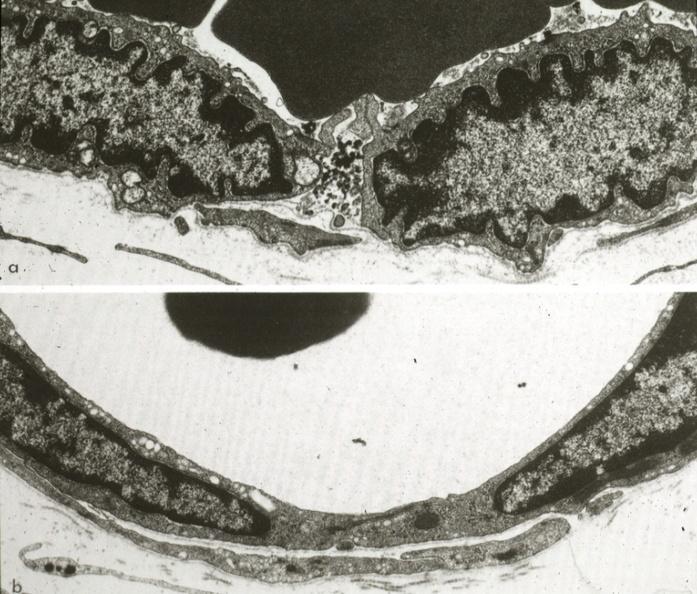what does this image show?
Answer the question using a single word or phrase. Continuous type illustrating opened and closed intercellular junction 